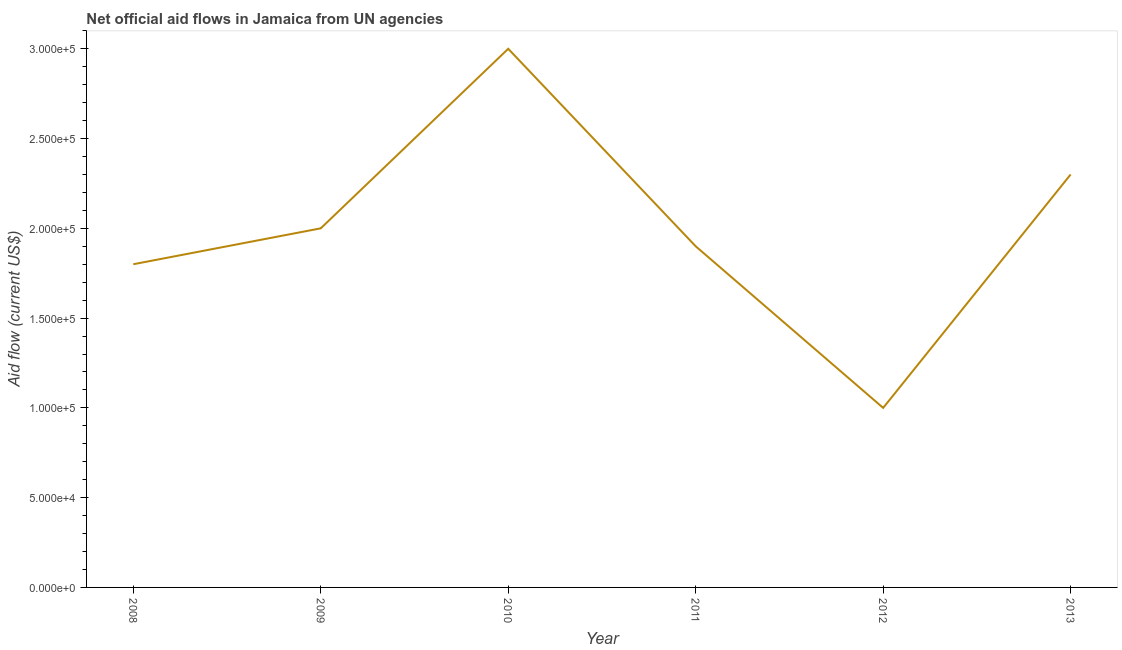What is the net official flows from un agencies in 2008?
Your response must be concise. 1.80e+05. Across all years, what is the maximum net official flows from un agencies?
Make the answer very short. 3.00e+05. Across all years, what is the minimum net official flows from un agencies?
Provide a succinct answer. 1.00e+05. In which year was the net official flows from un agencies maximum?
Provide a succinct answer. 2010. In which year was the net official flows from un agencies minimum?
Your answer should be very brief. 2012. What is the sum of the net official flows from un agencies?
Offer a very short reply. 1.20e+06. What is the difference between the net official flows from un agencies in 2011 and 2012?
Make the answer very short. 9.00e+04. What is the median net official flows from un agencies?
Make the answer very short. 1.95e+05. What is the ratio of the net official flows from un agencies in 2012 to that in 2013?
Your response must be concise. 0.43. Is the net official flows from un agencies in 2011 less than that in 2013?
Offer a terse response. Yes. Is the difference between the net official flows from un agencies in 2008 and 2009 greater than the difference between any two years?
Keep it short and to the point. No. What is the difference between the highest and the second highest net official flows from un agencies?
Ensure brevity in your answer.  7.00e+04. Is the sum of the net official flows from un agencies in 2011 and 2013 greater than the maximum net official flows from un agencies across all years?
Give a very brief answer. Yes. What is the difference between the highest and the lowest net official flows from un agencies?
Provide a succinct answer. 2.00e+05. In how many years, is the net official flows from un agencies greater than the average net official flows from un agencies taken over all years?
Offer a very short reply. 2. Does the net official flows from un agencies monotonically increase over the years?
Offer a terse response. No. How many lines are there?
Offer a terse response. 1. How many years are there in the graph?
Offer a terse response. 6. Does the graph contain any zero values?
Make the answer very short. No. Does the graph contain grids?
Offer a terse response. No. What is the title of the graph?
Your response must be concise. Net official aid flows in Jamaica from UN agencies. What is the label or title of the X-axis?
Make the answer very short. Year. What is the Aid flow (current US$) in 2010?
Give a very brief answer. 3.00e+05. What is the Aid flow (current US$) of 2011?
Ensure brevity in your answer.  1.90e+05. What is the Aid flow (current US$) of 2012?
Keep it short and to the point. 1.00e+05. What is the difference between the Aid flow (current US$) in 2008 and 2009?
Make the answer very short. -2.00e+04. What is the difference between the Aid flow (current US$) in 2008 and 2011?
Keep it short and to the point. -10000. What is the difference between the Aid flow (current US$) in 2008 and 2013?
Your answer should be very brief. -5.00e+04. What is the difference between the Aid flow (current US$) in 2009 and 2010?
Offer a very short reply. -1.00e+05. What is the difference between the Aid flow (current US$) in 2009 and 2011?
Your answer should be compact. 10000. What is the difference between the Aid flow (current US$) in 2010 and 2011?
Offer a very short reply. 1.10e+05. What is the difference between the Aid flow (current US$) in 2010 and 2012?
Offer a terse response. 2.00e+05. What is the ratio of the Aid flow (current US$) in 2008 to that in 2009?
Your answer should be compact. 0.9. What is the ratio of the Aid flow (current US$) in 2008 to that in 2010?
Ensure brevity in your answer.  0.6. What is the ratio of the Aid flow (current US$) in 2008 to that in 2011?
Make the answer very short. 0.95. What is the ratio of the Aid flow (current US$) in 2008 to that in 2013?
Ensure brevity in your answer.  0.78. What is the ratio of the Aid flow (current US$) in 2009 to that in 2010?
Make the answer very short. 0.67. What is the ratio of the Aid flow (current US$) in 2009 to that in 2011?
Provide a succinct answer. 1.05. What is the ratio of the Aid flow (current US$) in 2009 to that in 2013?
Your answer should be compact. 0.87. What is the ratio of the Aid flow (current US$) in 2010 to that in 2011?
Offer a very short reply. 1.58. What is the ratio of the Aid flow (current US$) in 2010 to that in 2012?
Provide a short and direct response. 3. What is the ratio of the Aid flow (current US$) in 2010 to that in 2013?
Provide a succinct answer. 1.3. What is the ratio of the Aid flow (current US$) in 2011 to that in 2013?
Offer a terse response. 0.83. What is the ratio of the Aid flow (current US$) in 2012 to that in 2013?
Offer a very short reply. 0.43. 